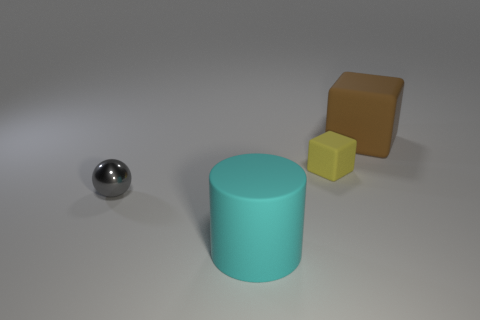Do the brown rubber thing and the tiny matte object have the same shape?
Offer a very short reply. Yes. Does the brown matte object have the same shape as the small object that is on the right side of the ball?
Provide a short and direct response. Yes. What size is the other thing that is the same shape as the yellow matte object?
Give a very brief answer. Large. How many objects are either big matte things that are left of the big brown rubber object or big cylinders?
Give a very brief answer. 1. What color is the large cube that is made of the same material as the large cyan cylinder?
Your response must be concise. Brown. Are there any gray objects that have the same size as the yellow matte thing?
Your answer should be compact. Yes. What number of objects are objects that are in front of the gray object or objects that are to the left of the small yellow object?
Your answer should be very brief. 2. What is the shape of the cyan rubber object that is the same size as the brown rubber block?
Give a very brief answer. Cylinder. Are there any other cyan objects that have the same shape as the cyan object?
Your answer should be compact. No. Is the number of matte cylinders less than the number of small purple rubber spheres?
Provide a short and direct response. No. 